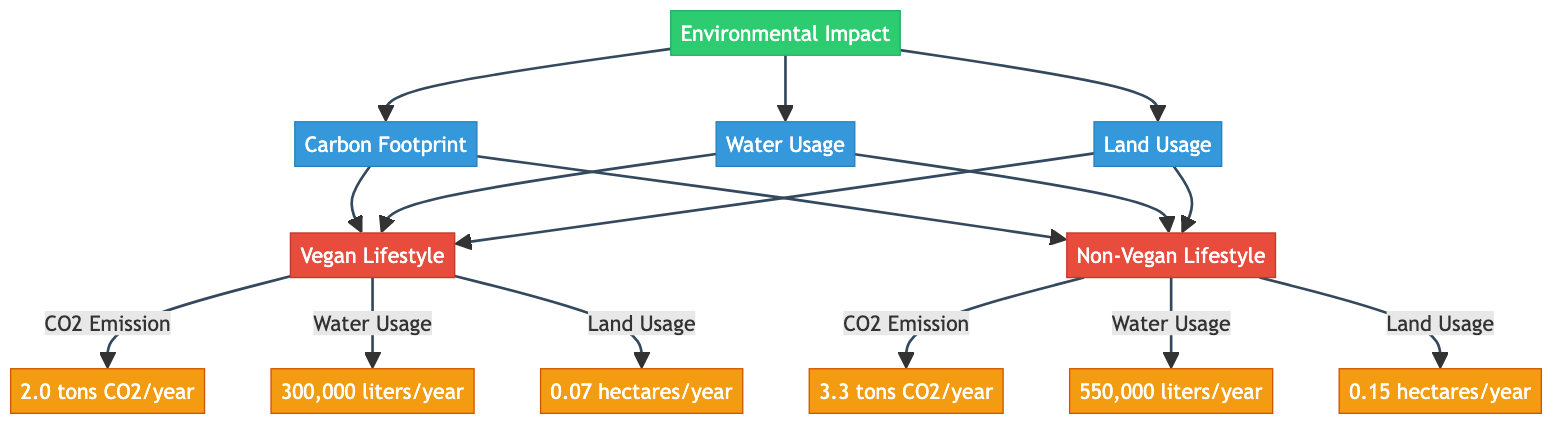What is the carbon footprint of a vegan lifestyle? The diagram states that the carbon footprint for a vegan lifestyle is 2.0 tons CO2/year, which is directly labeled under the vegan lifestyle category linked to carbon footprint.
Answer: 2.0 tons CO2/year What is the water usage for a non-vegan lifestyle? The diagram indicates that the water usage for a non-vegan lifestyle is 550,000 liters/year, which is specified under the non-vegan lifestyle category linked to water usage.
Answer: 550,000 liters/year How much land does a non-vegan lifestyle use per year? The diagram shows that the land usage for a non-vegan lifestyle is 0.15 hectares/year, clearly stated below the non-vegan lifestyle category associated with land usage.
Answer: 0.15 hectares/year Which lifestyle has a smaller carbon footprint? By comparing the carbon footprint values of both lifestyles, the vegan lifestyle has 2.0 tons CO2/year and the non-vegan lifestyle has 3.3 tons CO2/year. Therefore, vegan lifestyle has the smaller carbon footprint.
Answer: Vegan lifestyle What is the total water usage difference between vegan and non-vegan lifestyles? The water usage for vegan lifestyle is 300,000 liters/year, and for non-vegan lifestyle, it is 550,000 liters/year. The difference is calculated as 550,000 - 300,000, resulting in 250,000 liters/year more for non-vegan.
Answer: 250,000 liters/year Which category uses more land annually? The diagram provides data that the vegan lifestyle uses 0.07 hectares/year while the non-vegan lifestyle uses 0.15 hectares/year. Comparing these two, the non-vegan lifestyle uses more land.
Answer: Non-vegan lifestyle How many data points are presented in the environmental impact section? The diagram includes three categories: carbon footprint, water usage, and land usage, each having data points for both lifestyles. Thus, there are 6 data points in total (3 for vegan and 3 for non-vegan).
Answer: 6 data points What is the relationship between carbon footprint and land usage for both lifestyles? The diagram indicates that for both lifestyles, carbon footprint and land usage are connected to separate categories: the vegan lifestyle has a carbon footprint of 2.0 tons CO2/year and land usage of 0.07 hectares/year, while the non-vegan lifestyle has a carbon footprint of 3.3 tons CO2/year and land usage of 0.15 hectares/year. This establishes a relationship where both aspects are represented for each lifestyle but are distinctly measured without direct correlation.
Answer: No direct correlation In total, how much water do both lifestyles use combined? The vegan lifestyle uses 300,000 liters/year, whereas the non-vegan lifestyle uses 550,000 liters/year. Adding these values together: 300,000 + 550,000 results in a total of 850,000 liters/year for both lifestyles.
Answer: 850,000 liters/year 